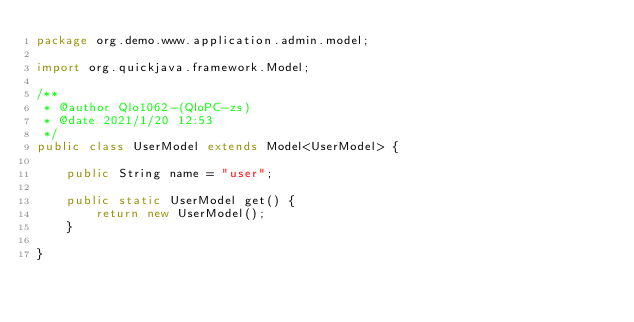Convert code to text. <code><loc_0><loc_0><loc_500><loc_500><_Java_>package org.demo.www.application.admin.model;

import org.quickjava.framework.Model;

/**
 * @author Qlo1062-(QloPC-zs)
 * @date 2021/1/20 12:53
 */
public class UserModel extends Model<UserModel> {

    public String name = "user";

    public static UserModel get() {
        return new UserModel();
    }

}
</code> 